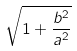Convert formula to latex. <formula><loc_0><loc_0><loc_500><loc_500>\sqrt { 1 + \frac { b ^ { 2 } } { a ^ { 2 } } }</formula> 